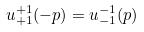<formula> <loc_0><loc_0><loc_500><loc_500>u _ { + 1 } ^ { + 1 } ( - p ) = u _ { - 1 } ^ { - 1 } ( p )</formula> 